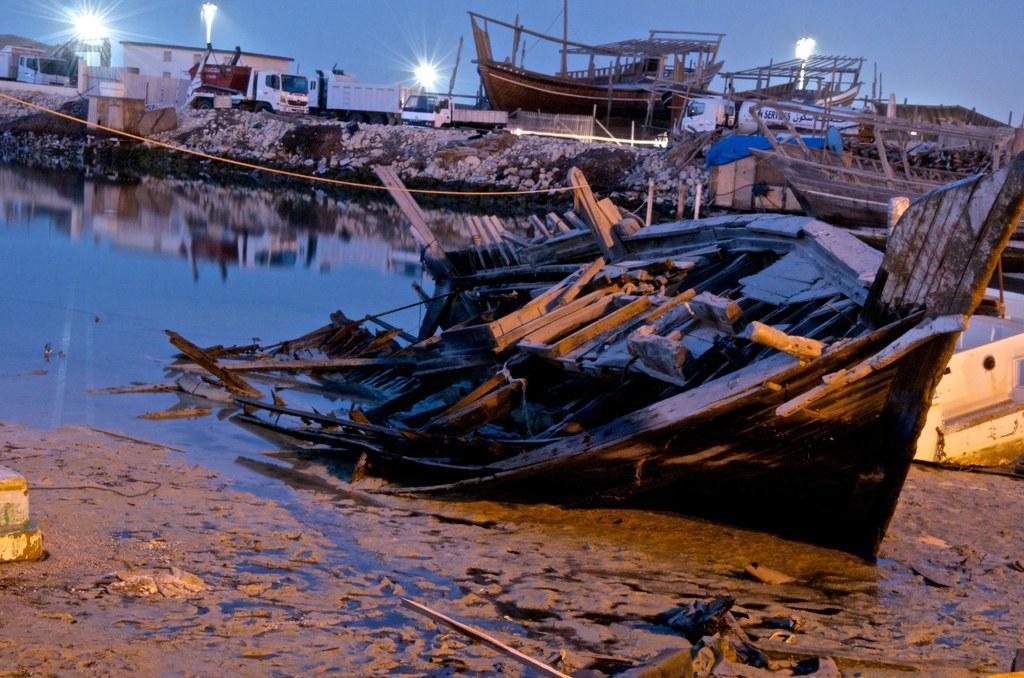How would you summarize this image in a sentence or two? In this image there is a wrecked boat, in front of the boat there is water, on the other side of the water, there are rocks, on top of the rocks there are boats, trucks and houses, in the background of the image there are lamp posts. 